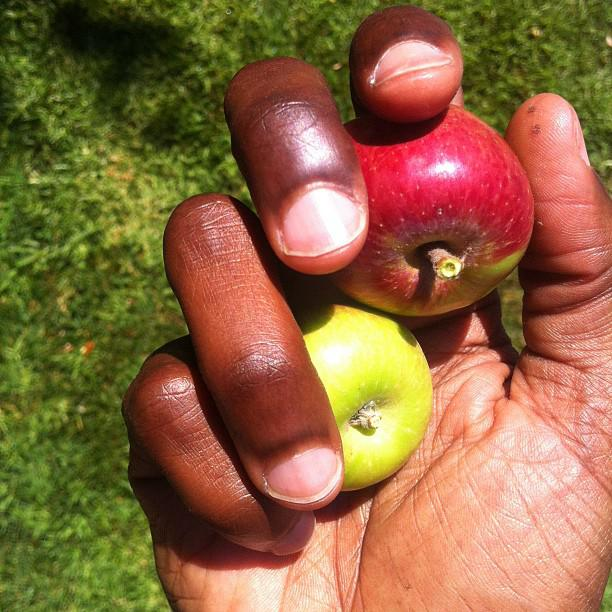Question: what is partially visible?
Choices:
A. A wristwatch.
B. Palm of hand.
C. The side of a face.
D. A left foot.
Answer with the letter. Answer: B Question: what is bent?
Choices:
A. A tree branch.
B. A metal rod.
C. Person's hand.
D. A u turn.
Answer with the letter. Answer: C Question: what is red and yellow?
Choices:
A. Flowers.
B. Apple.
C. Halloween candy.
D. Candy corn.
Answer with the letter. Answer: B Question: what is the hand holding?
Choices:
A. Apples.
B. Orranges.
C. Bananas.
D. Grapes.
Answer with the letter. Answer: A Question: why would someone want apples?
Choices:
A. To eat them.
B. To make juice.
C. To play with them.
D. To keep the doctor away.
Answer with the letter. Answer: A Question: who is holding the apples?
Choices:
A. A woman.
B. A dog.
C. A person.
D. A cat.
Answer with the letter. Answer: C Question: how many apples is the hand holding?
Choices:
A. Two.
B. Three.
C. Four.
D. Five.
Answer with the letter. Answer: A Question: where was this picture taken?
Choices:
A. At an intersection.
B. In a school.
C. In a library.
D. In a grassy location.
Answer with the letter. Answer: D Question: what is shining on the man's hand?
Choices:
A. The light.
B. The sun.
C. Reflection.
D. His ring.
Answer with the letter. Answer: B Question: how are the fingernails?
Choices:
A. Dirty.
B. Clean.
C. Cut short.
D. Painted pink.
Answer with the letter. Answer: C Question: what is the hand like?
Choices:
A. Tanned.
B. Browned.
C. Bruised.
D. Darkened.
Answer with the letter. Answer: A Question: what are the apples like?
Choices:
A. Small and with stems.
B. Large and with stems.
C. Medium and with stems.
D. Big and with stems.
Answer with the letter. Answer: A Question: what are the stems like?
Choices:
A. Long.
B. Wide.
C. Short.
D. Big.
Answer with the letter. Answer: C Question: what are the fingernails like?
Choices:
A. Dirty and long.
B. Clean and short.
C. Polish and short.
D. Sanitized and long.
Answer with the letter. Answer: B Question: what color are the nails?
Choices:
A. Black.
B. Brown.
C. Gray.
D. White.
Answer with the letter. Answer: D Question: what time of day is this?
Choices:
A. Night time.
B. Middle of the day.
C. Morning.
D. Day time.
Answer with the letter. Answer: D 